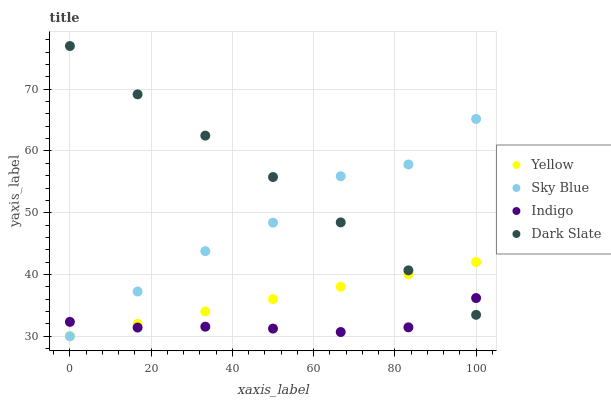Does Indigo have the minimum area under the curve?
Answer yes or no. Yes. Does Dark Slate have the maximum area under the curve?
Answer yes or no. Yes. Does Yellow have the minimum area under the curve?
Answer yes or no. No. Does Yellow have the maximum area under the curve?
Answer yes or no. No. Is Yellow the smoothest?
Answer yes or no. Yes. Is Sky Blue the roughest?
Answer yes or no. Yes. Is Indigo the smoothest?
Answer yes or no. No. Is Indigo the roughest?
Answer yes or no. No. Does Sky Blue have the lowest value?
Answer yes or no. Yes. Does Indigo have the lowest value?
Answer yes or no. No. Does Dark Slate have the highest value?
Answer yes or no. Yes. Does Yellow have the highest value?
Answer yes or no. No. Does Indigo intersect Sky Blue?
Answer yes or no. Yes. Is Indigo less than Sky Blue?
Answer yes or no. No. Is Indigo greater than Sky Blue?
Answer yes or no. No. 